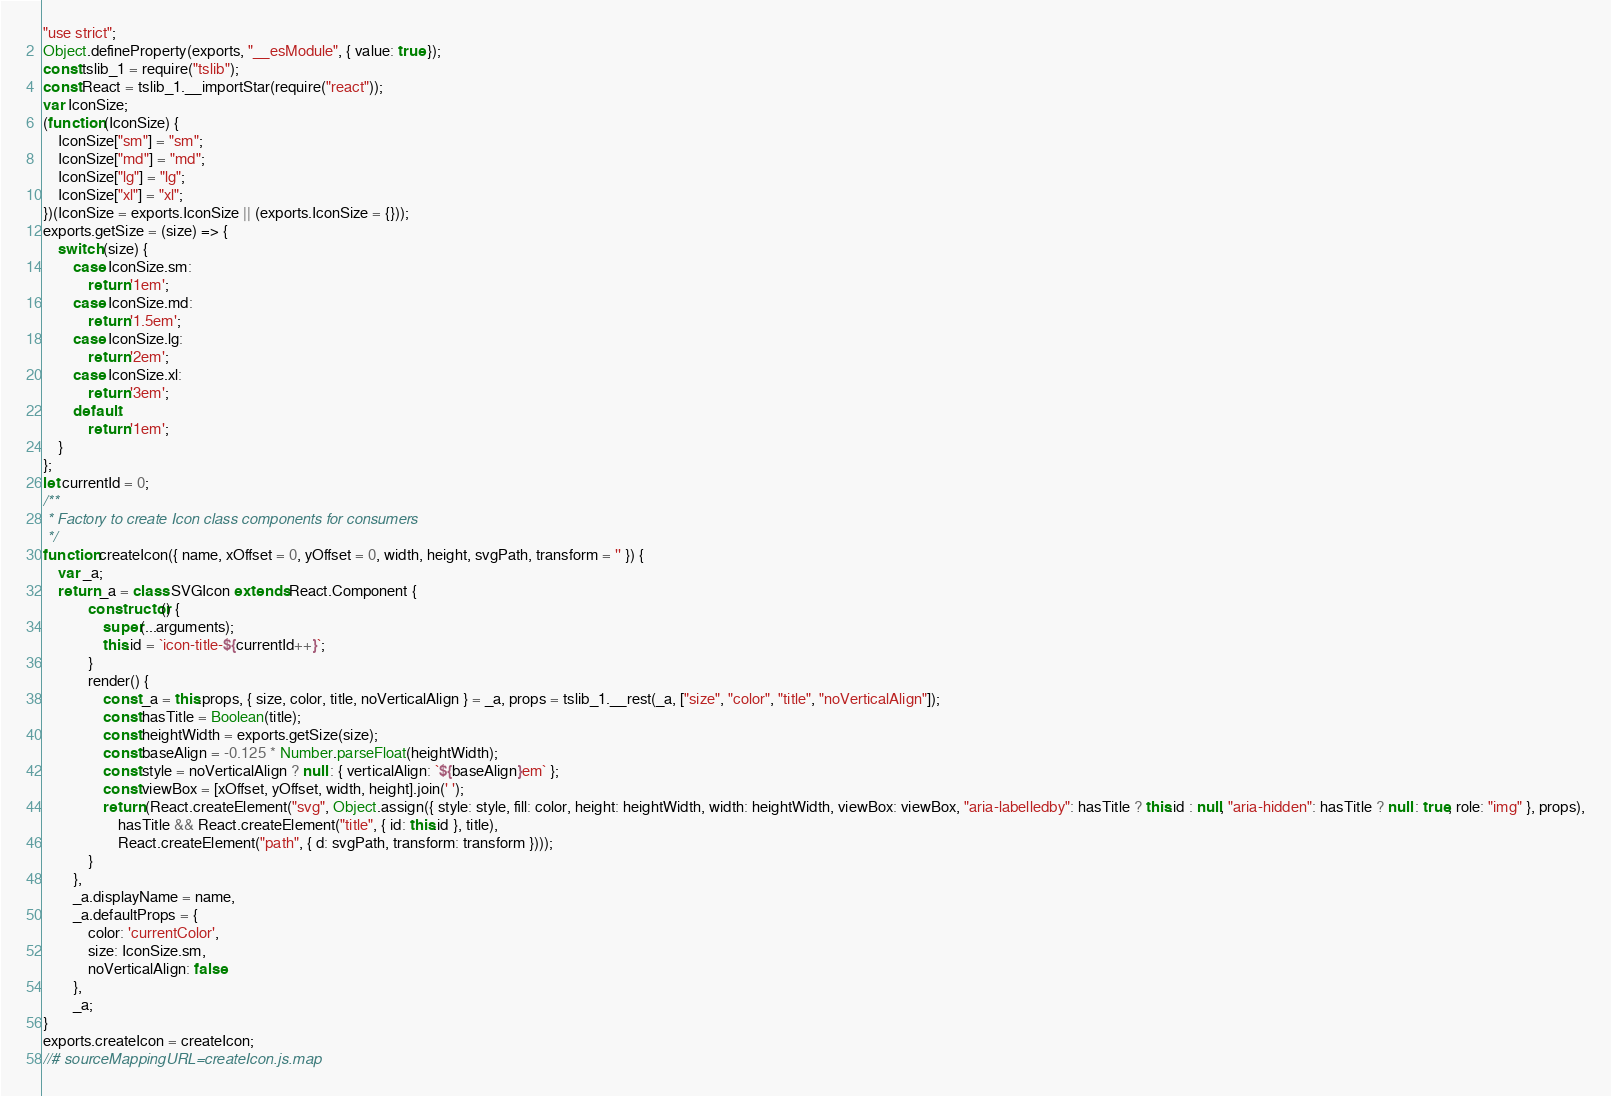Convert code to text. <code><loc_0><loc_0><loc_500><loc_500><_JavaScript_>"use strict";
Object.defineProperty(exports, "__esModule", { value: true });
const tslib_1 = require("tslib");
const React = tslib_1.__importStar(require("react"));
var IconSize;
(function (IconSize) {
    IconSize["sm"] = "sm";
    IconSize["md"] = "md";
    IconSize["lg"] = "lg";
    IconSize["xl"] = "xl";
})(IconSize = exports.IconSize || (exports.IconSize = {}));
exports.getSize = (size) => {
    switch (size) {
        case IconSize.sm:
            return '1em';
        case IconSize.md:
            return '1.5em';
        case IconSize.lg:
            return '2em';
        case IconSize.xl:
            return '3em';
        default:
            return '1em';
    }
};
let currentId = 0;
/**
 * Factory to create Icon class components for consumers
 */
function createIcon({ name, xOffset = 0, yOffset = 0, width, height, svgPath, transform = '' }) {
    var _a;
    return _a = class SVGIcon extends React.Component {
            constructor() {
                super(...arguments);
                this.id = `icon-title-${currentId++}`;
            }
            render() {
                const _a = this.props, { size, color, title, noVerticalAlign } = _a, props = tslib_1.__rest(_a, ["size", "color", "title", "noVerticalAlign"]);
                const hasTitle = Boolean(title);
                const heightWidth = exports.getSize(size);
                const baseAlign = -0.125 * Number.parseFloat(heightWidth);
                const style = noVerticalAlign ? null : { verticalAlign: `${baseAlign}em` };
                const viewBox = [xOffset, yOffset, width, height].join(' ');
                return (React.createElement("svg", Object.assign({ style: style, fill: color, height: heightWidth, width: heightWidth, viewBox: viewBox, "aria-labelledby": hasTitle ? this.id : null, "aria-hidden": hasTitle ? null : true, role: "img" }, props),
                    hasTitle && React.createElement("title", { id: this.id }, title),
                    React.createElement("path", { d: svgPath, transform: transform })));
            }
        },
        _a.displayName = name,
        _a.defaultProps = {
            color: 'currentColor',
            size: IconSize.sm,
            noVerticalAlign: false
        },
        _a;
}
exports.createIcon = createIcon;
//# sourceMappingURL=createIcon.js.map</code> 